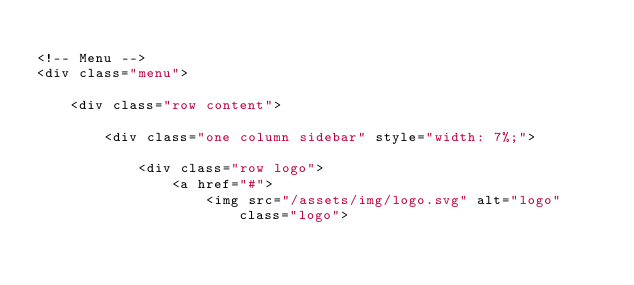Convert code to text. <code><loc_0><loc_0><loc_500><loc_500><_PHP_>
<!-- Menu -->
<div class="menu">
    
    <div class="row content">
        
        <div class="one column sidebar" style="width: 7%;">
            
            <div class="row logo">
                <a href="#">
                    <img src="/assets/img/logo.svg" alt="logo" class="logo"></code> 